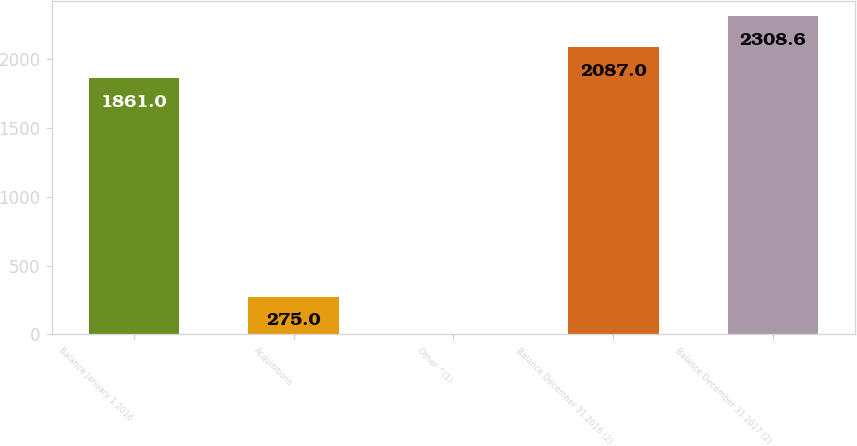Convert chart to OTSL. <chart><loc_0><loc_0><loc_500><loc_500><bar_chart><fcel>Balance January 1 2016<fcel>Acquisitions<fcel>Other ^(1)<fcel>Balance December 31 2016 (2)<fcel>Balance December 31 2017 (2)<nl><fcel>1861<fcel>275<fcel>2<fcel>2087<fcel>2308.6<nl></chart> 